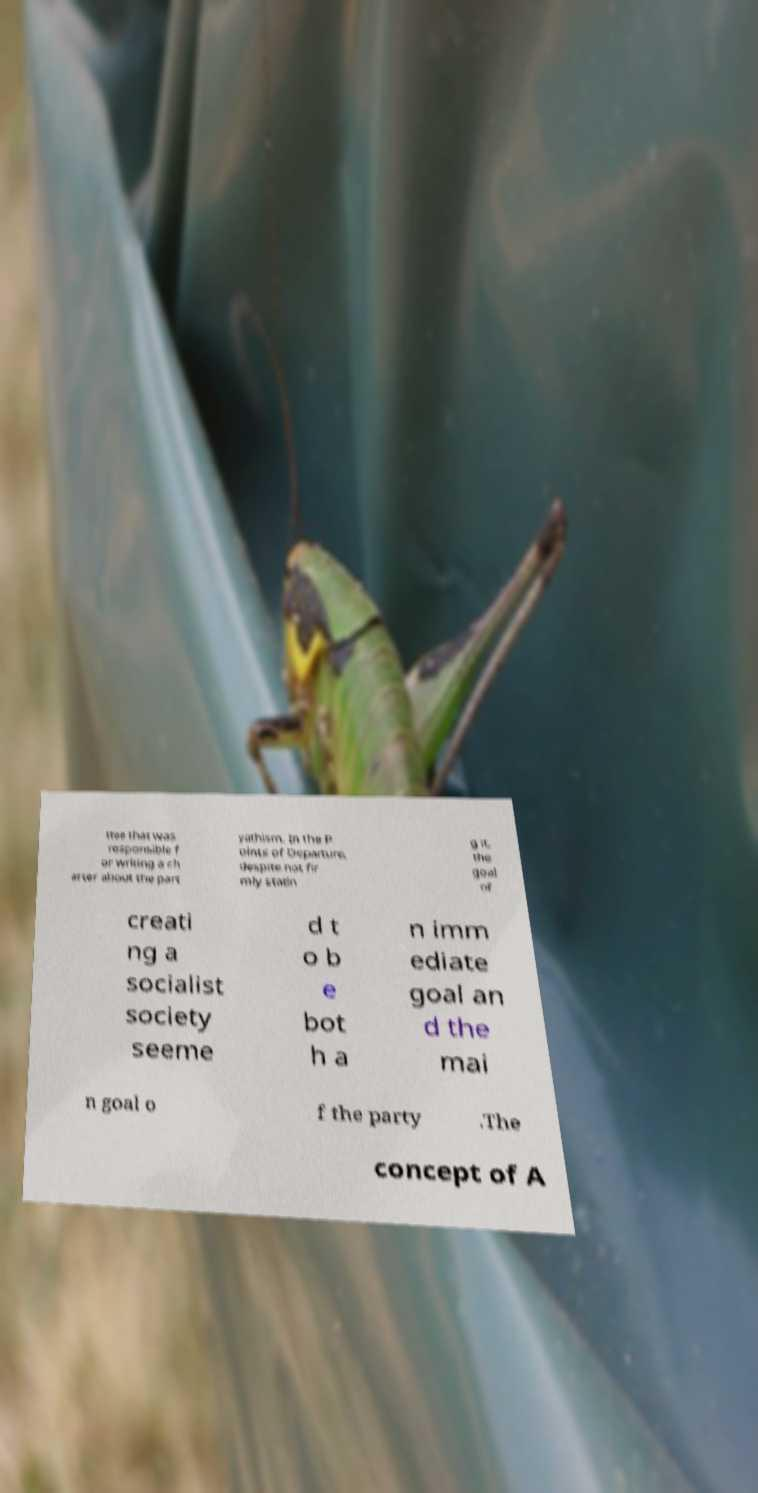Please identify and transcribe the text found in this image. ttee that was responsible f or writing a ch arter about the part yathism. In the P oints of Departure, despite not fir mly statin g it, the goal of creati ng a socialist society seeme d t o b e bot h a n imm ediate goal an d the mai n goal o f the party .The concept of A 